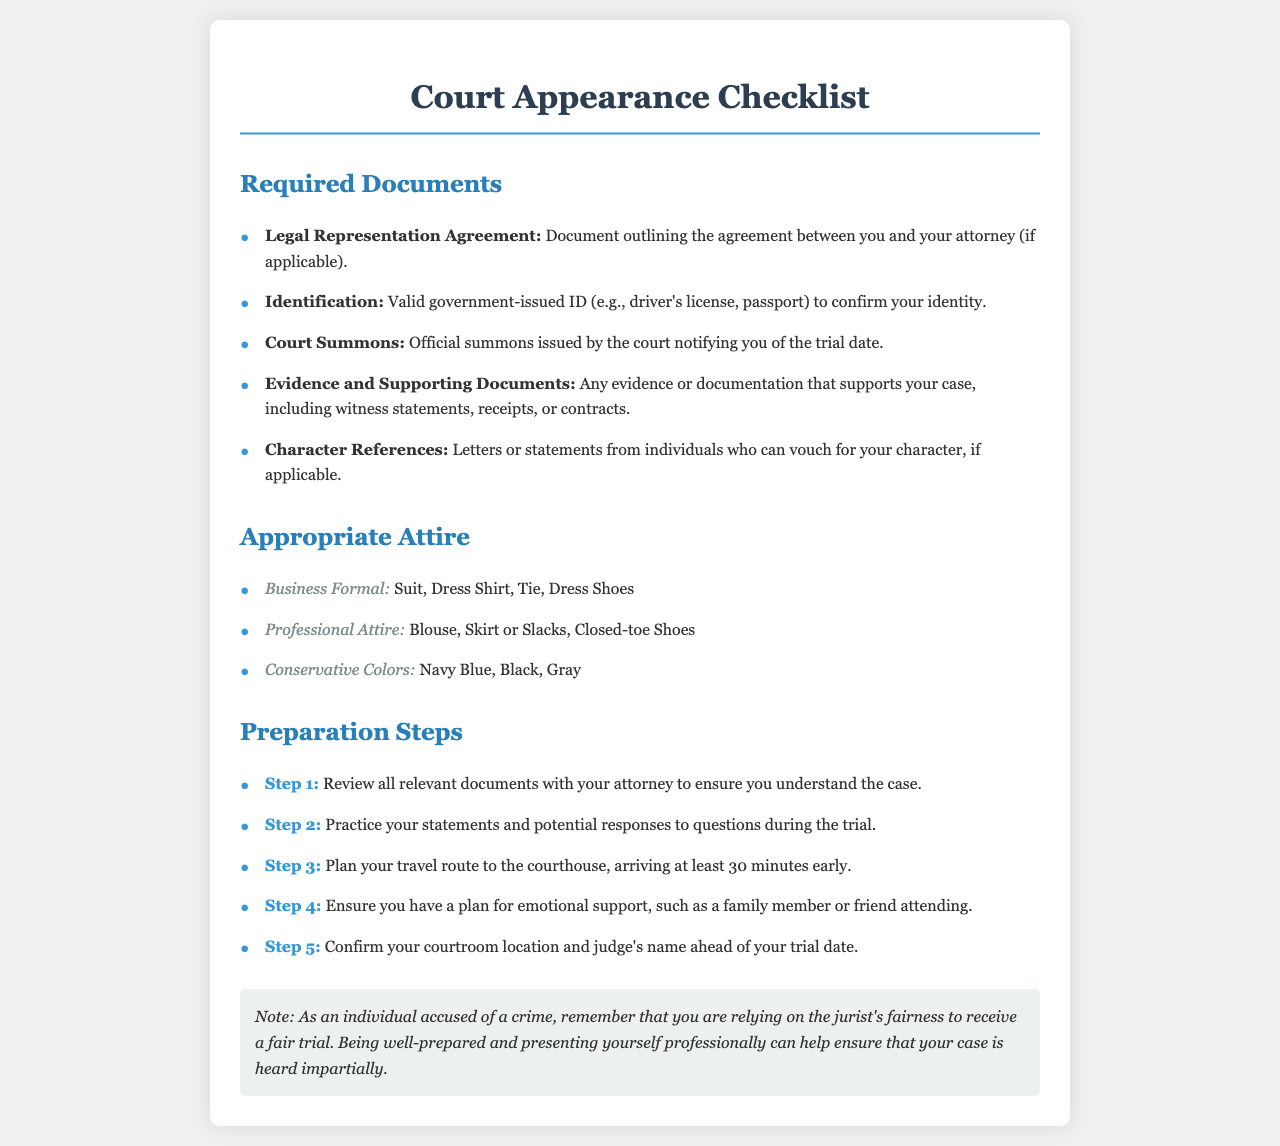What is the first required document listed? The first required document in the checklist is the "Legal Representation Agreement."
Answer: Legal Representation Agreement What type of identification is required? The document specifies that a valid government-issued ID is needed for identification.
Answer: Valid government-issued ID What attire is classified as business formal? The document lists suit, dress shirt, tie, and dress shoes as business formal attire.
Answer: Suit, Dress Shirt, Tie, Dress Shoes What is the third preparation step? The document states that planning your travel route to the courthouse is the third preparation step.
Answer: Plan your travel route to the courthouse What color attire is recommended in the appropriate attire section? The document mentions conservative colors like navy blue, black, and gray are recommended.
Answer: Navy Blue, Black, Gray How many documents are listed under required documents? The document lists a total of five required documents.
Answer: Five Why is it important to arrive at least 30 minutes early? The document implies arriving early allows for proper preparation before the trial begins.
Answer: Proper preparation What theme is emphasized in the note at the end of the checklist? The note emphasizes relying on the jurist's fairness to receive a fair trial as important.
Answer: Jurist's fairness Which step involves practicing your statements? The second step in the preparation section involves practicing your statements and responses.
Answer: Practice your statements 